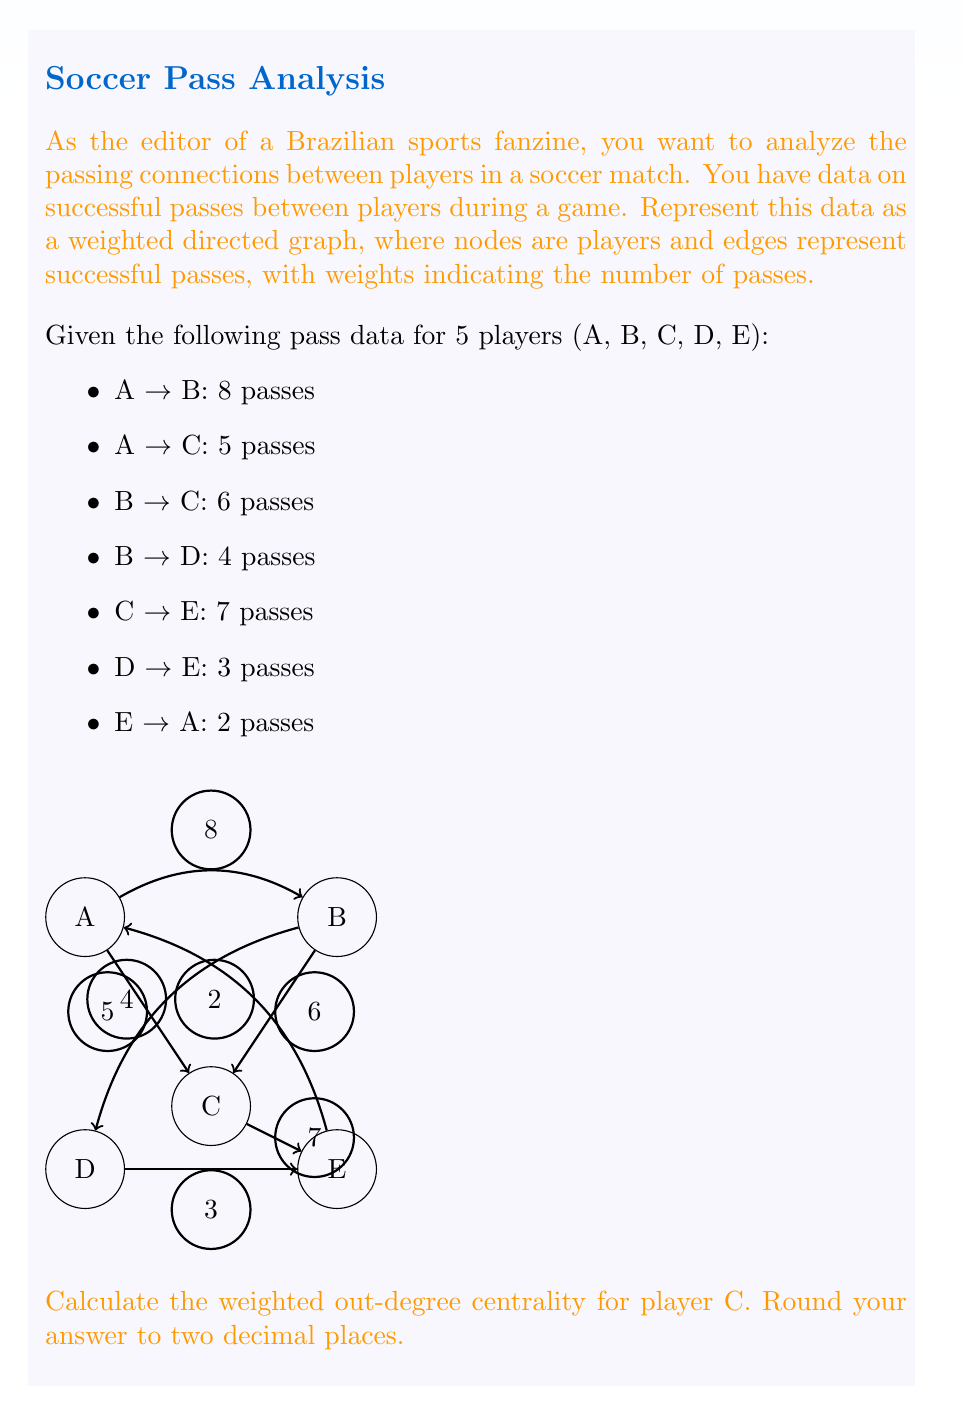Teach me how to tackle this problem. To solve this problem, we need to understand and apply the concept of weighted out-degree centrality in a directed graph. Here's a step-by-step explanation:

1) Out-degree centrality measures the number of outgoing connections from a node. In a weighted graph, we sum the weights of these connections.

2) For player C, we need to identify all outgoing passes and their weights:
   C → E: 7 passes

3) The weighted out-degree centrality is calculated by summing these weights:
   $$\text{Weighted Out-Degree}(C) = 7$$

4) To normalize this value and make it comparable across different graph sizes, we divide by the maximum possible out-degree. In a directed graph with n nodes, the maximum out-degree is (n-1) multiplied by the maximum edge weight.

5) In this case:
   n = 5 (total number of players)
   Maximum edge weight = 8 (A → B has the highest weight)

6) The normalization calculation:
   $$\text{Normalized Weighted Out-Degree}(C) = \frac{7}{(5-1) \times 8} = \frac{7}{32} = 0.21875$$

7) Rounding to two decimal places: 0.22

This normalized value represents the proportion of C's outgoing passes relative to the maximum possible in the network, providing a measure of C's influence in distributing the ball.
Answer: 0.22 